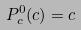Convert formula to latex. <formula><loc_0><loc_0><loc_500><loc_500>P _ { c } ^ { 0 } ( c ) = c</formula> 